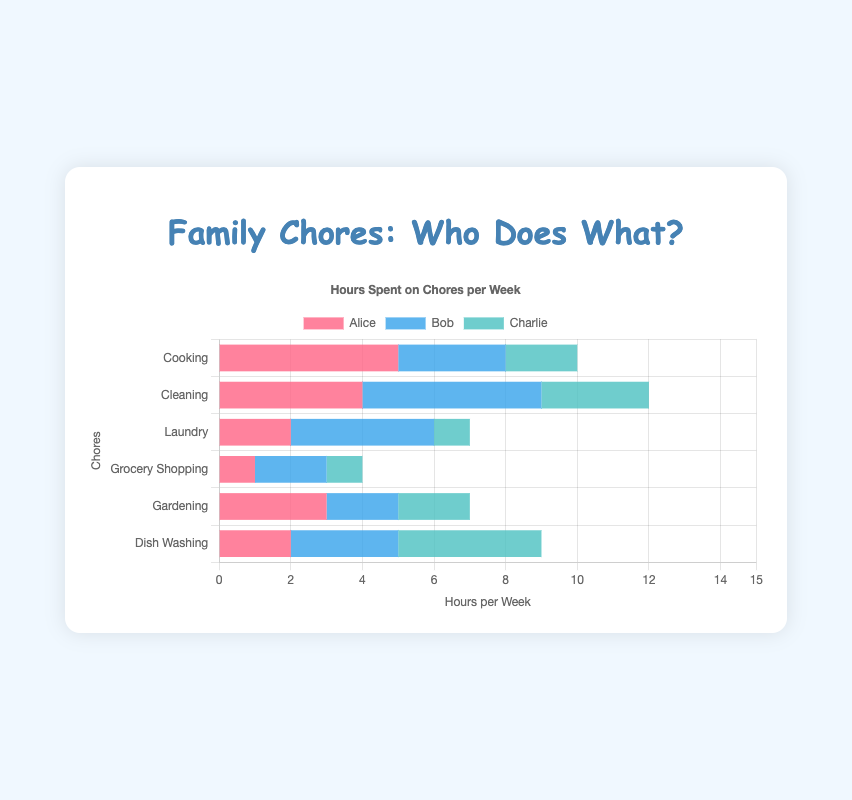What household chore does Alice spend the most time on? By looking at Alice's bars across all chores, the highest one is for Cooking at 5 hours per week.
Answer: Cooking How much more time does Bob spend on Cleaning compared to Laundry? Bob spends 5 hours per week on Cleaning and 4 hours per week on Laundry. The difference is 5 - 4 = 1 hour.
Answer: 1 hour Which household chore takes the least time for Charlie? Looking at Charlie's bars across all chores, the lowest one is for Laundry at 1 hour per week.
Answer: Laundry How many total hours does the family spend on Cooking per week? Add up the hours spent on Cooking by Alice (5), Bob (3), and Charlie (2): 5 + 3 + 2 = 10 hours per week.
Answer: 10 hours What is the average time spent on Gardening by the family per week? Add up the hours spent on Gardening by Alice (3), Bob (2), and Charlie (2), and divide by 3: (3 + 2 + 2)/3 = 7/3 ≈ 2.33 hours per week.
Answer: ~2.33 hours Does Charlie or Bob spend more time washing dishes? Charlie spends 4 hours per week compared to Bob's 3 hours per week, so Charlie spends more time.
Answer: Charlie Which household chore has the highest combined time spent by all family members? By adding the hours for each chore across Alice, Bob, and Charlie: Cooking (10), Cleaning (12), Laundry (7), Grocery Shopping (4), Gardening (7), Dish Washing (9), the highest is Cleaning at 12 hours per week.
Answer: Cleaning What is the total time spent on household chores by Alice per week? Sum Alice's hours across all chores: 5 (Cooking) + 4 (Cleaning) + 2 (Laundry) + 1 (Grocery Shopping) + 3 (Gardening) + 2 (Dish Washing) = 17 hours per week.
Answer: 17 hours Who spends the most time on Grocery Shopping per week? Both Alice and Charlie spend 1 hour each, while Bob spends 2 hours, so Bob spends the most time.
Answer: Bob 